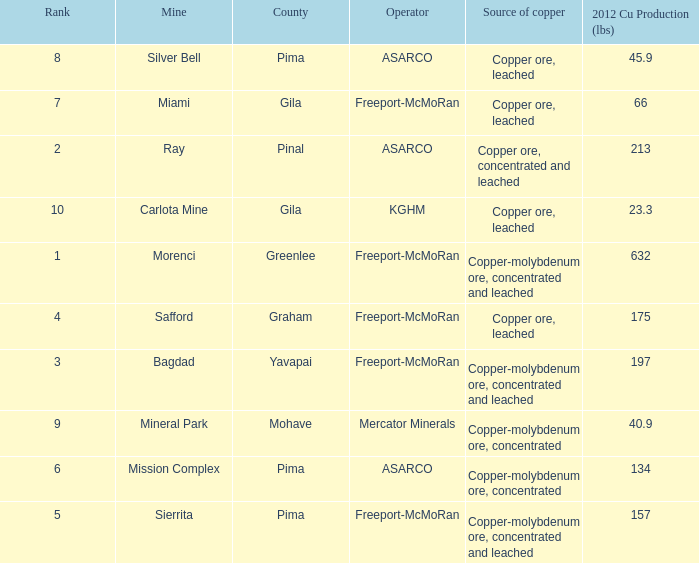What's the lowest ranking source of copper, copper ore, concentrated and leached? 2.0. 